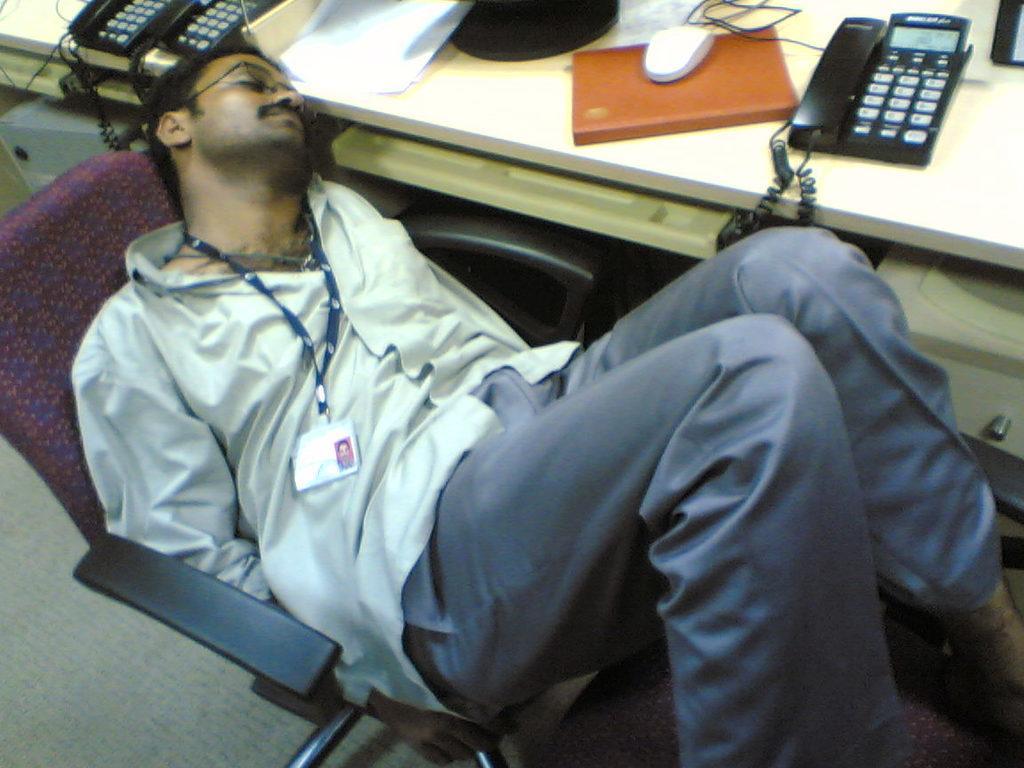How would you summarize this image in a sentence or two? In this image I see a man who is wearing shirt and pants and I see that he is lying on a chair and I see a table over here on which there are telephones, a mouse and other things and I see the floor. 